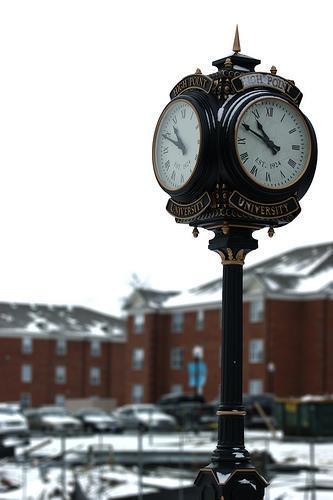How many clocks are there?
Give a very brief answer. 2. 